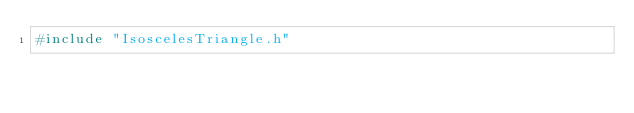Convert code to text. <code><loc_0><loc_0><loc_500><loc_500><_C++_>#include "IsoscelesTriangle.h"
</code> 